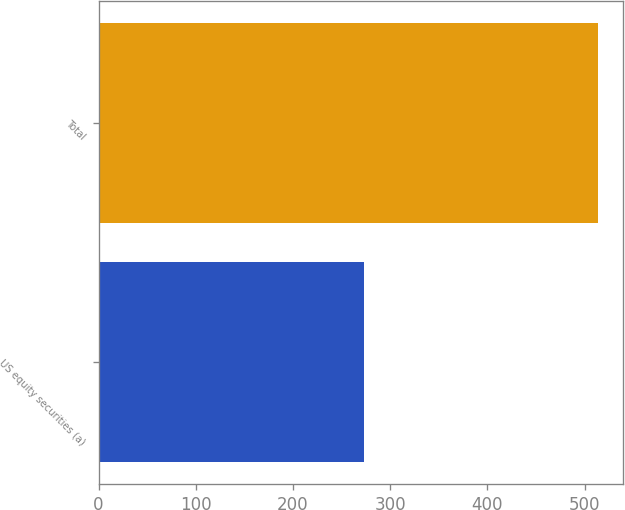Convert chart to OTSL. <chart><loc_0><loc_0><loc_500><loc_500><bar_chart><fcel>US equity securities (a)<fcel>Total<nl><fcel>273<fcel>514.1<nl></chart> 